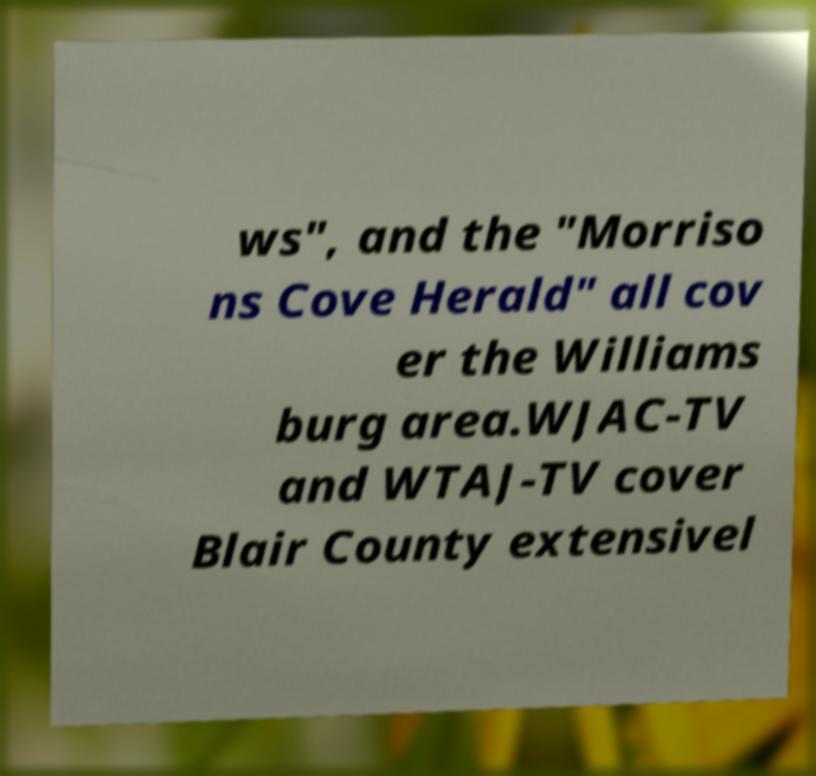Can you read and provide the text displayed in the image?This photo seems to have some interesting text. Can you extract and type it out for me? ws", and the "Morriso ns Cove Herald" all cov er the Williams burg area.WJAC-TV and WTAJ-TV cover Blair County extensivel 